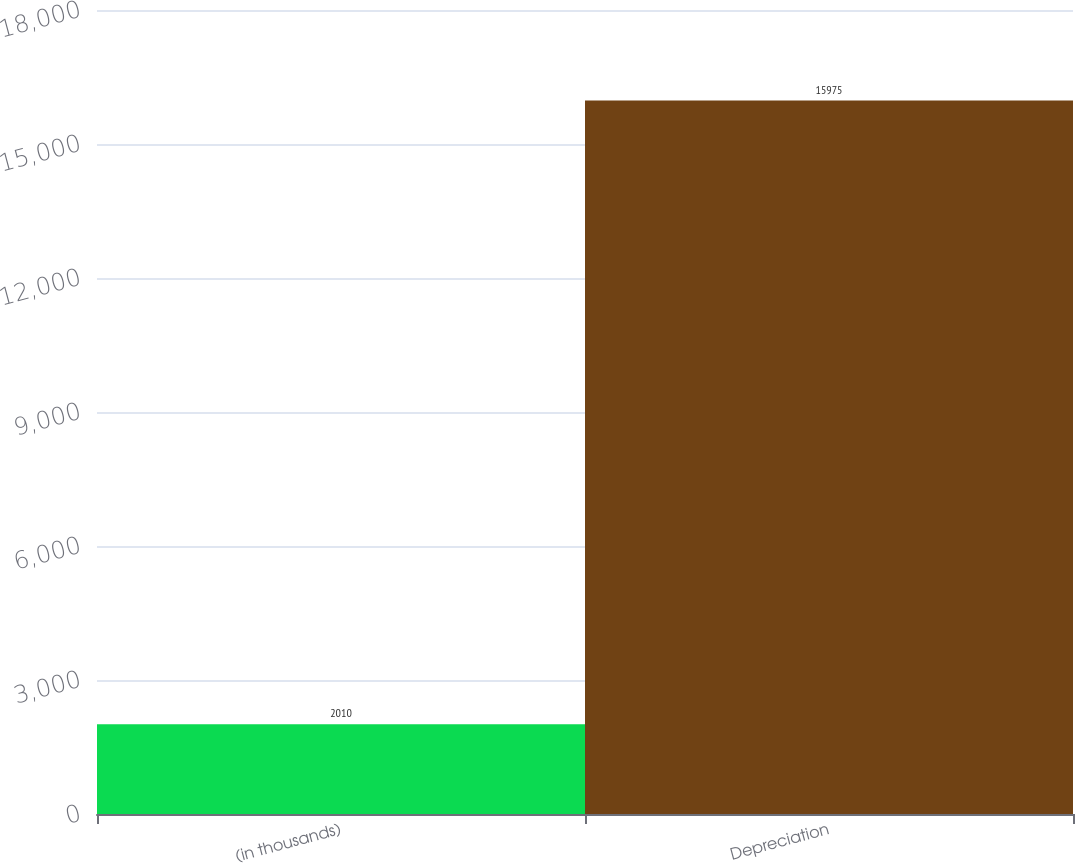Convert chart to OTSL. <chart><loc_0><loc_0><loc_500><loc_500><bar_chart><fcel>(in thousands)<fcel>Depreciation<nl><fcel>2010<fcel>15975<nl></chart> 